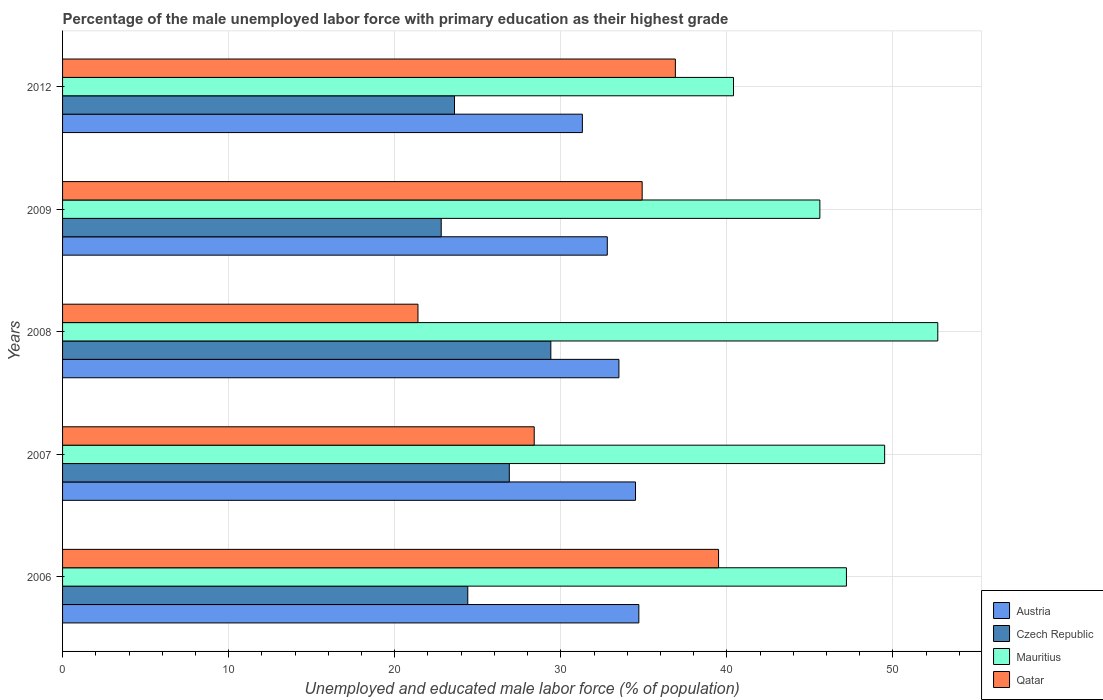How many different coloured bars are there?
Offer a very short reply. 4. How many bars are there on the 5th tick from the bottom?
Make the answer very short. 4. What is the label of the 4th group of bars from the top?
Make the answer very short. 2007. In how many cases, is the number of bars for a given year not equal to the number of legend labels?
Make the answer very short. 0. What is the percentage of the unemployed male labor force with primary education in Austria in 2008?
Make the answer very short. 33.5. Across all years, what is the maximum percentage of the unemployed male labor force with primary education in Czech Republic?
Ensure brevity in your answer.  29.4. Across all years, what is the minimum percentage of the unemployed male labor force with primary education in Mauritius?
Provide a short and direct response. 40.4. In which year was the percentage of the unemployed male labor force with primary education in Czech Republic maximum?
Your answer should be very brief. 2008. In which year was the percentage of the unemployed male labor force with primary education in Austria minimum?
Offer a terse response. 2012. What is the total percentage of the unemployed male labor force with primary education in Mauritius in the graph?
Offer a terse response. 235.4. What is the difference between the percentage of the unemployed male labor force with primary education in Qatar in 2006 and that in 2012?
Ensure brevity in your answer.  2.6. What is the difference between the percentage of the unemployed male labor force with primary education in Qatar in 2009 and the percentage of the unemployed male labor force with primary education in Austria in 2012?
Make the answer very short. 3.6. What is the average percentage of the unemployed male labor force with primary education in Austria per year?
Your response must be concise. 33.36. In the year 2008, what is the difference between the percentage of the unemployed male labor force with primary education in Austria and percentage of the unemployed male labor force with primary education in Qatar?
Your response must be concise. 12.1. In how many years, is the percentage of the unemployed male labor force with primary education in Austria greater than 26 %?
Ensure brevity in your answer.  5. What is the ratio of the percentage of the unemployed male labor force with primary education in Austria in 2007 to that in 2009?
Your response must be concise. 1.05. Is the percentage of the unemployed male labor force with primary education in Qatar in 2009 less than that in 2012?
Keep it short and to the point. Yes. Is the difference between the percentage of the unemployed male labor force with primary education in Austria in 2006 and 2009 greater than the difference between the percentage of the unemployed male labor force with primary education in Qatar in 2006 and 2009?
Give a very brief answer. No. What is the difference between the highest and the second highest percentage of the unemployed male labor force with primary education in Czech Republic?
Offer a very short reply. 2.5. What is the difference between the highest and the lowest percentage of the unemployed male labor force with primary education in Mauritius?
Provide a short and direct response. 12.3. In how many years, is the percentage of the unemployed male labor force with primary education in Austria greater than the average percentage of the unemployed male labor force with primary education in Austria taken over all years?
Offer a terse response. 3. What does the 1st bar from the top in 2006 represents?
Your answer should be very brief. Qatar. What does the 3rd bar from the bottom in 2009 represents?
Ensure brevity in your answer.  Mauritius. Is it the case that in every year, the sum of the percentage of the unemployed male labor force with primary education in Qatar and percentage of the unemployed male labor force with primary education in Czech Republic is greater than the percentage of the unemployed male labor force with primary education in Austria?
Your answer should be very brief. Yes. How many years are there in the graph?
Offer a very short reply. 5. Are the values on the major ticks of X-axis written in scientific E-notation?
Offer a terse response. No. Where does the legend appear in the graph?
Provide a short and direct response. Bottom right. How many legend labels are there?
Provide a short and direct response. 4. What is the title of the graph?
Offer a terse response. Percentage of the male unemployed labor force with primary education as their highest grade. What is the label or title of the X-axis?
Make the answer very short. Unemployed and educated male labor force (% of population). What is the label or title of the Y-axis?
Provide a short and direct response. Years. What is the Unemployed and educated male labor force (% of population) of Austria in 2006?
Offer a very short reply. 34.7. What is the Unemployed and educated male labor force (% of population) in Czech Republic in 2006?
Offer a very short reply. 24.4. What is the Unemployed and educated male labor force (% of population) in Mauritius in 2006?
Keep it short and to the point. 47.2. What is the Unemployed and educated male labor force (% of population) of Qatar in 2006?
Provide a succinct answer. 39.5. What is the Unemployed and educated male labor force (% of population) in Austria in 2007?
Give a very brief answer. 34.5. What is the Unemployed and educated male labor force (% of population) of Czech Republic in 2007?
Offer a terse response. 26.9. What is the Unemployed and educated male labor force (% of population) of Mauritius in 2007?
Ensure brevity in your answer.  49.5. What is the Unemployed and educated male labor force (% of population) of Qatar in 2007?
Give a very brief answer. 28.4. What is the Unemployed and educated male labor force (% of population) of Austria in 2008?
Provide a short and direct response. 33.5. What is the Unemployed and educated male labor force (% of population) in Czech Republic in 2008?
Your answer should be very brief. 29.4. What is the Unemployed and educated male labor force (% of population) of Mauritius in 2008?
Your answer should be compact. 52.7. What is the Unemployed and educated male labor force (% of population) in Qatar in 2008?
Keep it short and to the point. 21.4. What is the Unemployed and educated male labor force (% of population) in Austria in 2009?
Keep it short and to the point. 32.8. What is the Unemployed and educated male labor force (% of population) in Czech Republic in 2009?
Your response must be concise. 22.8. What is the Unemployed and educated male labor force (% of population) of Mauritius in 2009?
Give a very brief answer. 45.6. What is the Unemployed and educated male labor force (% of population) of Qatar in 2009?
Ensure brevity in your answer.  34.9. What is the Unemployed and educated male labor force (% of population) of Austria in 2012?
Provide a succinct answer. 31.3. What is the Unemployed and educated male labor force (% of population) of Czech Republic in 2012?
Make the answer very short. 23.6. What is the Unemployed and educated male labor force (% of population) in Mauritius in 2012?
Your answer should be compact. 40.4. What is the Unemployed and educated male labor force (% of population) in Qatar in 2012?
Offer a terse response. 36.9. Across all years, what is the maximum Unemployed and educated male labor force (% of population) in Austria?
Offer a terse response. 34.7. Across all years, what is the maximum Unemployed and educated male labor force (% of population) in Czech Republic?
Your response must be concise. 29.4. Across all years, what is the maximum Unemployed and educated male labor force (% of population) in Mauritius?
Keep it short and to the point. 52.7. Across all years, what is the maximum Unemployed and educated male labor force (% of population) in Qatar?
Keep it short and to the point. 39.5. Across all years, what is the minimum Unemployed and educated male labor force (% of population) in Austria?
Provide a short and direct response. 31.3. Across all years, what is the minimum Unemployed and educated male labor force (% of population) of Czech Republic?
Keep it short and to the point. 22.8. Across all years, what is the minimum Unemployed and educated male labor force (% of population) in Mauritius?
Your answer should be very brief. 40.4. Across all years, what is the minimum Unemployed and educated male labor force (% of population) of Qatar?
Make the answer very short. 21.4. What is the total Unemployed and educated male labor force (% of population) of Austria in the graph?
Offer a very short reply. 166.8. What is the total Unemployed and educated male labor force (% of population) of Czech Republic in the graph?
Offer a terse response. 127.1. What is the total Unemployed and educated male labor force (% of population) in Mauritius in the graph?
Provide a short and direct response. 235.4. What is the total Unemployed and educated male labor force (% of population) in Qatar in the graph?
Ensure brevity in your answer.  161.1. What is the difference between the Unemployed and educated male labor force (% of population) in Austria in 2006 and that in 2007?
Provide a short and direct response. 0.2. What is the difference between the Unemployed and educated male labor force (% of population) of Czech Republic in 2006 and that in 2007?
Your answer should be very brief. -2.5. What is the difference between the Unemployed and educated male labor force (% of population) of Qatar in 2006 and that in 2007?
Your answer should be compact. 11.1. What is the difference between the Unemployed and educated male labor force (% of population) of Czech Republic in 2006 and that in 2008?
Keep it short and to the point. -5. What is the difference between the Unemployed and educated male labor force (% of population) in Qatar in 2006 and that in 2008?
Your answer should be compact. 18.1. What is the difference between the Unemployed and educated male labor force (% of population) of Austria in 2006 and that in 2009?
Provide a short and direct response. 1.9. What is the difference between the Unemployed and educated male labor force (% of population) of Czech Republic in 2006 and that in 2009?
Provide a short and direct response. 1.6. What is the difference between the Unemployed and educated male labor force (% of population) in Mauritius in 2006 and that in 2009?
Keep it short and to the point. 1.6. What is the difference between the Unemployed and educated male labor force (% of population) of Austria in 2006 and that in 2012?
Your answer should be compact. 3.4. What is the difference between the Unemployed and educated male labor force (% of population) in Czech Republic in 2006 and that in 2012?
Offer a terse response. 0.8. What is the difference between the Unemployed and educated male labor force (% of population) in Mauritius in 2006 and that in 2012?
Make the answer very short. 6.8. What is the difference between the Unemployed and educated male labor force (% of population) of Austria in 2007 and that in 2008?
Offer a very short reply. 1. What is the difference between the Unemployed and educated male labor force (% of population) of Czech Republic in 2007 and that in 2008?
Keep it short and to the point. -2.5. What is the difference between the Unemployed and educated male labor force (% of population) of Austria in 2007 and that in 2009?
Offer a terse response. 1.7. What is the difference between the Unemployed and educated male labor force (% of population) of Mauritius in 2007 and that in 2009?
Give a very brief answer. 3.9. What is the difference between the Unemployed and educated male labor force (% of population) in Qatar in 2007 and that in 2009?
Ensure brevity in your answer.  -6.5. What is the difference between the Unemployed and educated male labor force (% of population) in Austria in 2008 and that in 2009?
Offer a very short reply. 0.7. What is the difference between the Unemployed and educated male labor force (% of population) of Czech Republic in 2008 and that in 2009?
Keep it short and to the point. 6.6. What is the difference between the Unemployed and educated male labor force (% of population) of Mauritius in 2008 and that in 2009?
Offer a terse response. 7.1. What is the difference between the Unemployed and educated male labor force (% of population) of Qatar in 2008 and that in 2009?
Ensure brevity in your answer.  -13.5. What is the difference between the Unemployed and educated male labor force (% of population) in Austria in 2008 and that in 2012?
Offer a terse response. 2.2. What is the difference between the Unemployed and educated male labor force (% of population) in Czech Republic in 2008 and that in 2012?
Offer a terse response. 5.8. What is the difference between the Unemployed and educated male labor force (% of population) of Qatar in 2008 and that in 2012?
Your answer should be compact. -15.5. What is the difference between the Unemployed and educated male labor force (% of population) of Austria in 2009 and that in 2012?
Offer a very short reply. 1.5. What is the difference between the Unemployed and educated male labor force (% of population) in Austria in 2006 and the Unemployed and educated male labor force (% of population) in Czech Republic in 2007?
Offer a terse response. 7.8. What is the difference between the Unemployed and educated male labor force (% of population) in Austria in 2006 and the Unemployed and educated male labor force (% of population) in Mauritius in 2007?
Offer a terse response. -14.8. What is the difference between the Unemployed and educated male labor force (% of population) of Austria in 2006 and the Unemployed and educated male labor force (% of population) of Qatar in 2007?
Give a very brief answer. 6.3. What is the difference between the Unemployed and educated male labor force (% of population) of Czech Republic in 2006 and the Unemployed and educated male labor force (% of population) of Mauritius in 2007?
Offer a terse response. -25.1. What is the difference between the Unemployed and educated male labor force (% of population) in Czech Republic in 2006 and the Unemployed and educated male labor force (% of population) in Mauritius in 2008?
Your answer should be compact. -28.3. What is the difference between the Unemployed and educated male labor force (% of population) of Czech Republic in 2006 and the Unemployed and educated male labor force (% of population) of Qatar in 2008?
Your response must be concise. 3. What is the difference between the Unemployed and educated male labor force (% of population) in Mauritius in 2006 and the Unemployed and educated male labor force (% of population) in Qatar in 2008?
Make the answer very short. 25.8. What is the difference between the Unemployed and educated male labor force (% of population) of Austria in 2006 and the Unemployed and educated male labor force (% of population) of Qatar in 2009?
Your answer should be compact. -0.2. What is the difference between the Unemployed and educated male labor force (% of population) of Czech Republic in 2006 and the Unemployed and educated male labor force (% of population) of Mauritius in 2009?
Your answer should be compact. -21.2. What is the difference between the Unemployed and educated male labor force (% of population) of Austria in 2006 and the Unemployed and educated male labor force (% of population) of Czech Republic in 2012?
Give a very brief answer. 11.1. What is the difference between the Unemployed and educated male labor force (% of population) in Czech Republic in 2006 and the Unemployed and educated male labor force (% of population) in Mauritius in 2012?
Offer a terse response. -16. What is the difference between the Unemployed and educated male labor force (% of population) of Mauritius in 2006 and the Unemployed and educated male labor force (% of population) of Qatar in 2012?
Ensure brevity in your answer.  10.3. What is the difference between the Unemployed and educated male labor force (% of population) of Austria in 2007 and the Unemployed and educated male labor force (% of population) of Mauritius in 2008?
Offer a very short reply. -18.2. What is the difference between the Unemployed and educated male labor force (% of population) in Austria in 2007 and the Unemployed and educated male labor force (% of population) in Qatar in 2008?
Make the answer very short. 13.1. What is the difference between the Unemployed and educated male labor force (% of population) in Czech Republic in 2007 and the Unemployed and educated male labor force (% of population) in Mauritius in 2008?
Ensure brevity in your answer.  -25.8. What is the difference between the Unemployed and educated male labor force (% of population) in Czech Republic in 2007 and the Unemployed and educated male labor force (% of population) in Qatar in 2008?
Provide a short and direct response. 5.5. What is the difference between the Unemployed and educated male labor force (% of population) in Mauritius in 2007 and the Unemployed and educated male labor force (% of population) in Qatar in 2008?
Your answer should be compact. 28.1. What is the difference between the Unemployed and educated male labor force (% of population) in Austria in 2007 and the Unemployed and educated male labor force (% of population) in Czech Republic in 2009?
Your answer should be very brief. 11.7. What is the difference between the Unemployed and educated male labor force (% of population) in Austria in 2007 and the Unemployed and educated male labor force (% of population) in Mauritius in 2009?
Offer a terse response. -11.1. What is the difference between the Unemployed and educated male labor force (% of population) of Czech Republic in 2007 and the Unemployed and educated male labor force (% of population) of Mauritius in 2009?
Provide a succinct answer. -18.7. What is the difference between the Unemployed and educated male labor force (% of population) of Austria in 2007 and the Unemployed and educated male labor force (% of population) of Czech Republic in 2012?
Provide a short and direct response. 10.9. What is the difference between the Unemployed and educated male labor force (% of population) in Czech Republic in 2007 and the Unemployed and educated male labor force (% of population) in Mauritius in 2012?
Offer a very short reply. -13.5. What is the difference between the Unemployed and educated male labor force (% of population) in Mauritius in 2007 and the Unemployed and educated male labor force (% of population) in Qatar in 2012?
Ensure brevity in your answer.  12.6. What is the difference between the Unemployed and educated male labor force (% of population) of Austria in 2008 and the Unemployed and educated male labor force (% of population) of Czech Republic in 2009?
Offer a terse response. 10.7. What is the difference between the Unemployed and educated male labor force (% of population) of Austria in 2008 and the Unemployed and educated male labor force (% of population) of Qatar in 2009?
Your answer should be compact. -1.4. What is the difference between the Unemployed and educated male labor force (% of population) in Czech Republic in 2008 and the Unemployed and educated male labor force (% of population) in Mauritius in 2009?
Provide a short and direct response. -16.2. What is the difference between the Unemployed and educated male labor force (% of population) in Mauritius in 2008 and the Unemployed and educated male labor force (% of population) in Qatar in 2009?
Provide a short and direct response. 17.8. What is the difference between the Unemployed and educated male labor force (% of population) of Austria in 2008 and the Unemployed and educated male labor force (% of population) of Czech Republic in 2012?
Offer a very short reply. 9.9. What is the difference between the Unemployed and educated male labor force (% of population) of Austria in 2008 and the Unemployed and educated male labor force (% of population) of Mauritius in 2012?
Give a very brief answer. -6.9. What is the difference between the Unemployed and educated male labor force (% of population) of Czech Republic in 2008 and the Unemployed and educated male labor force (% of population) of Qatar in 2012?
Provide a succinct answer. -7.5. What is the difference between the Unemployed and educated male labor force (% of population) in Mauritius in 2008 and the Unemployed and educated male labor force (% of population) in Qatar in 2012?
Your response must be concise. 15.8. What is the difference between the Unemployed and educated male labor force (% of population) in Austria in 2009 and the Unemployed and educated male labor force (% of population) in Czech Republic in 2012?
Offer a very short reply. 9.2. What is the difference between the Unemployed and educated male labor force (% of population) of Czech Republic in 2009 and the Unemployed and educated male labor force (% of population) of Mauritius in 2012?
Give a very brief answer. -17.6. What is the difference between the Unemployed and educated male labor force (% of population) in Czech Republic in 2009 and the Unemployed and educated male labor force (% of population) in Qatar in 2012?
Offer a very short reply. -14.1. What is the difference between the Unemployed and educated male labor force (% of population) of Mauritius in 2009 and the Unemployed and educated male labor force (% of population) of Qatar in 2012?
Offer a terse response. 8.7. What is the average Unemployed and educated male labor force (% of population) in Austria per year?
Provide a short and direct response. 33.36. What is the average Unemployed and educated male labor force (% of population) in Czech Republic per year?
Offer a terse response. 25.42. What is the average Unemployed and educated male labor force (% of population) in Mauritius per year?
Give a very brief answer. 47.08. What is the average Unemployed and educated male labor force (% of population) of Qatar per year?
Offer a very short reply. 32.22. In the year 2006, what is the difference between the Unemployed and educated male labor force (% of population) of Czech Republic and Unemployed and educated male labor force (% of population) of Mauritius?
Give a very brief answer. -22.8. In the year 2006, what is the difference between the Unemployed and educated male labor force (% of population) of Czech Republic and Unemployed and educated male labor force (% of population) of Qatar?
Make the answer very short. -15.1. In the year 2007, what is the difference between the Unemployed and educated male labor force (% of population) of Austria and Unemployed and educated male labor force (% of population) of Czech Republic?
Make the answer very short. 7.6. In the year 2007, what is the difference between the Unemployed and educated male labor force (% of population) of Czech Republic and Unemployed and educated male labor force (% of population) of Mauritius?
Offer a very short reply. -22.6. In the year 2007, what is the difference between the Unemployed and educated male labor force (% of population) in Czech Republic and Unemployed and educated male labor force (% of population) in Qatar?
Offer a terse response. -1.5. In the year 2007, what is the difference between the Unemployed and educated male labor force (% of population) of Mauritius and Unemployed and educated male labor force (% of population) of Qatar?
Offer a very short reply. 21.1. In the year 2008, what is the difference between the Unemployed and educated male labor force (% of population) in Austria and Unemployed and educated male labor force (% of population) in Mauritius?
Make the answer very short. -19.2. In the year 2008, what is the difference between the Unemployed and educated male labor force (% of population) of Czech Republic and Unemployed and educated male labor force (% of population) of Mauritius?
Your answer should be very brief. -23.3. In the year 2008, what is the difference between the Unemployed and educated male labor force (% of population) of Mauritius and Unemployed and educated male labor force (% of population) of Qatar?
Give a very brief answer. 31.3. In the year 2009, what is the difference between the Unemployed and educated male labor force (% of population) of Austria and Unemployed and educated male labor force (% of population) of Mauritius?
Provide a succinct answer. -12.8. In the year 2009, what is the difference between the Unemployed and educated male labor force (% of population) in Czech Republic and Unemployed and educated male labor force (% of population) in Mauritius?
Offer a terse response. -22.8. In the year 2009, what is the difference between the Unemployed and educated male labor force (% of population) in Mauritius and Unemployed and educated male labor force (% of population) in Qatar?
Make the answer very short. 10.7. In the year 2012, what is the difference between the Unemployed and educated male labor force (% of population) of Austria and Unemployed and educated male labor force (% of population) of Mauritius?
Offer a very short reply. -9.1. In the year 2012, what is the difference between the Unemployed and educated male labor force (% of population) in Austria and Unemployed and educated male labor force (% of population) in Qatar?
Give a very brief answer. -5.6. In the year 2012, what is the difference between the Unemployed and educated male labor force (% of population) of Czech Republic and Unemployed and educated male labor force (% of population) of Mauritius?
Make the answer very short. -16.8. What is the ratio of the Unemployed and educated male labor force (% of population) in Austria in 2006 to that in 2007?
Give a very brief answer. 1.01. What is the ratio of the Unemployed and educated male labor force (% of population) of Czech Republic in 2006 to that in 2007?
Give a very brief answer. 0.91. What is the ratio of the Unemployed and educated male labor force (% of population) in Mauritius in 2006 to that in 2007?
Offer a terse response. 0.95. What is the ratio of the Unemployed and educated male labor force (% of population) of Qatar in 2006 to that in 2007?
Make the answer very short. 1.39. What is the ratio of the Unemployed and educated male labor force (% of population) in Austria in 2006 to that in 2008?
Your response must be concise. 1.04. What is the ratio of the Unemployed and educated male labor force (% of population) of Czech Republic in 2006 to that in 2008?
Keep it short and to the point. 0.83. What is the ratio of the Unemployed and educated male labor force (% of population) in Mauritius in 2006 to that in 2008?
Offer a very short reply. 0.9. What is the ratio of the Unemployed and educated male labor force (% of population) in Qatar in 2006 to that in 2008?
Ensure brevity in your answer.  1.85. What is the ratio of the Unemployed and educated male labor force (% of population) of Austria in 2006 to that in 2009?
Your answer should be compact. 1.06. What is the ratio of the Unemployed and educated male labor force (% of population) in Czech Republic in 2006 to that in 2009?
Your answer should be very brief. 1.07. What is the ratio of the Unemployed and educated male labor force (% of population) in Mauritius in 2006 to that in 2009?
Your answer should be very brief. 1.04. What is the ratio of the Unemployed and educated male labor force (% of population) of Qatar in 2006 to that in 2009?
Offer a very short reply. 1.13. What is the ratio of the Unemployed and educated male labor force (% of population) of Austria in 2006 to that in 2012?
Provide a succinct answer. 1.11. What is the ratio of the Unemployed and educated male labor force (% of population) of Czech Republic in 2006 to that in 2012?
Give a very brief answer. 1.03. What is the ratio of the Unemployed and educated male labor force (% of population) of Mauritius in 2006 to that in 2012?
Keep it short and to the point. 1.17. What is the ratio of the Unemployed and educated male labor force (% of population) of Qatar in 2006 to that in 2012?
Your response must be concise. 1.07. What is the ratio of the Unemployed and educated male labor force (% of population) of Austria in 2007 to that in 2008?
Your answer should be very brief. 1.03. What is the ratio of the Unemployed and educated male labor force (% of population) in Czech Republic in 2007 to that in 2008?
Offer a terse response. 0.92. What is the ratio of the Unemployed and educated male labor force (% of population) of Mauritius in 2007 to that in 2008?
Your answer should be very brief. 0.94. What is the ratio of the Unemployed and educated male labor force (% of population) in Qatar in 2007 to that in 2008?
Your response must be concise. 1.33. What is the ratio of the Unemployed and educated male labor force (% of population) in Austria in 2007 to that in 2009?
Ensure brevity in your answer.  1.05. What is the ratio of the Unemployed and educated male labor force (% of population) in Czech Republic in 2007 to that in 2009?
Your answer should be compact. 1.18. What is the ratio of the Unemployed and educated male labor force (% of population) in Mauritius in 2007 to that in 2009?
Provide a succinct answer. 1.09. What is the ratio of the Unemployed and educated male labor force (% of population) in Qatar in 2007 to that in 2009?
Provide a short and direct response. 0.81. What is the ratio of the Unemployed and educated male labor force (% of population) in Austria in 2007 to that in 2012?
Your answer should be compact. 1.1. What is the ratio of the Unemployed and educated male labor force (% of population) of Czech Republic in 2007 to that in 2012?
Your answer should be compact. 1.14. What is the ratio of the Unemployed and educated male labor force (% of population) in Mauritius in 2007 to that in 2012?
Your response must be concise. 1.23. What is the ratio of the Unemployed and educated male labor force (% of population) in Qatar in 2007 to that in 2012?
Provide a short and direct response. 0.77. What is the ratio of the Unemployed and educated male labor force (% of population) of Austria in 2008 to that in 2009?
Offer a very short reply. 1.02. What is the ratio of the Unemployed and educated male labor force (% of population) in Czech Republic in 2008 to that in 2009?
Your answer should be compact. 1.29. What is the ratio of the Unemployed and educated male labor force (% of population) of Mauritius in 2008 to that in 2009?
Your answer should be very brief. 1.16. What is the ratio of the Unemployed and educated male labor force (% of population) of Qatar in 2008 to that in 2009?
Provide a short and direct response. 0.61. What is the ratio of the Unemployed and educated male labor force (% of population) in Austria in 2008 to that in 2012?
Your answer should be very brief. 1.07. What is the ratio of the Unemployed and educated male labor force (% of population) of Czech Republic in 2008 to that in 2012?
Keep it short and to the point. 1.25. What is the ratio of the Unemployed and educated male labor force (% of population) of Mauritius in 2008 to that in 2012?
Offer a terse response. 1.3. What is the ratio of the Unemployed and educated male labor force (% of population) in Qatar in 2008 to that in 2012?
Your answer should be very brief. 0.58. What is the ratio of the Unemployed and educated male labor force (% of population) in Austria in 2009 to that in 2012?
Provide a short and direct response. 1.05. What is the ratio of the Unemployed and educated male labor force (% of population) of Czech Republic in 2009 to that in 2012?
Your answer should be very brief. 0.97. What is the ratio of the Unemployed and educated male labor force (% of population) in Mauritius in 2009 to that in 2012?
Provide a short and direct response. 1.13. What is the ratio of the Unemployed and educated male labor force (% of population) in Qatar in 2009 to that in 2012?
Offer a very short reply. 0.95. What is the difference between the highest and the second highest Unemployed and educated male labor force (% of population) in Austria?
Ensure brevity in your answer.  0.2. What is the difference between the highest and the second highest Unemployed and educated male labor force (% of population) in Qatar?
Provide a succinct answer. 2.6. What is the difference between the highest and the lowest Unemployed and educated male labor force (% of population) in Qatar?
Your answer should be very brief. 18.1. 